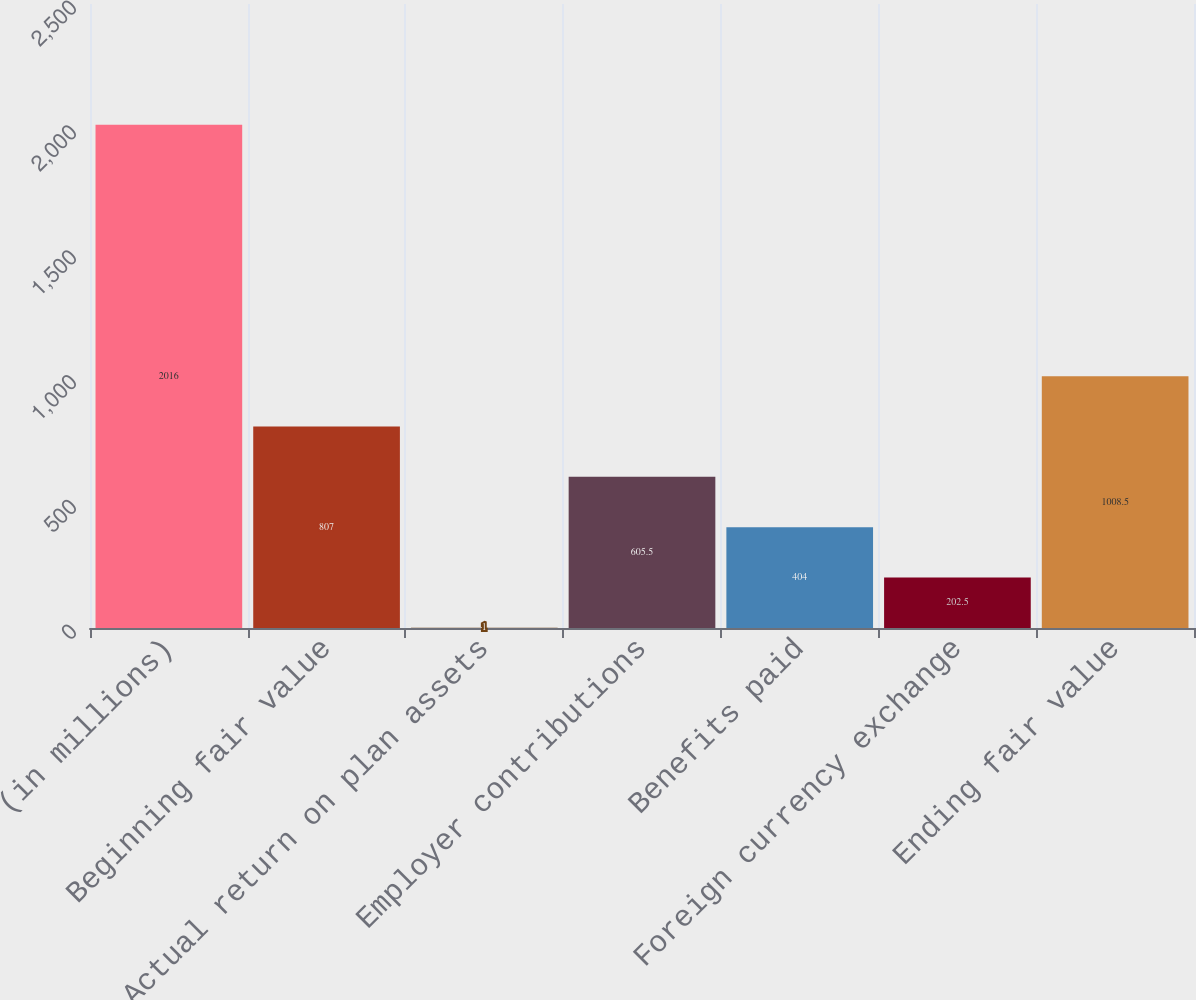Convert chart to OTSL. <chart><loc_0><loc_0><loc_500><loc_500><bar_chart><fcel>(in millions)<fcel>Beginning fair value<fcel>Actual return on plan assets<fcel>Employer contributions<fcel>Benefits paid<fcel>Foreign currency exchange<fcel>Ending fair value<nl><fcel>2016<fcel>807<fcel>1<fcel>605.5<fcel>404<fcel>202.5<fcel>1008.5<nl></chart> 